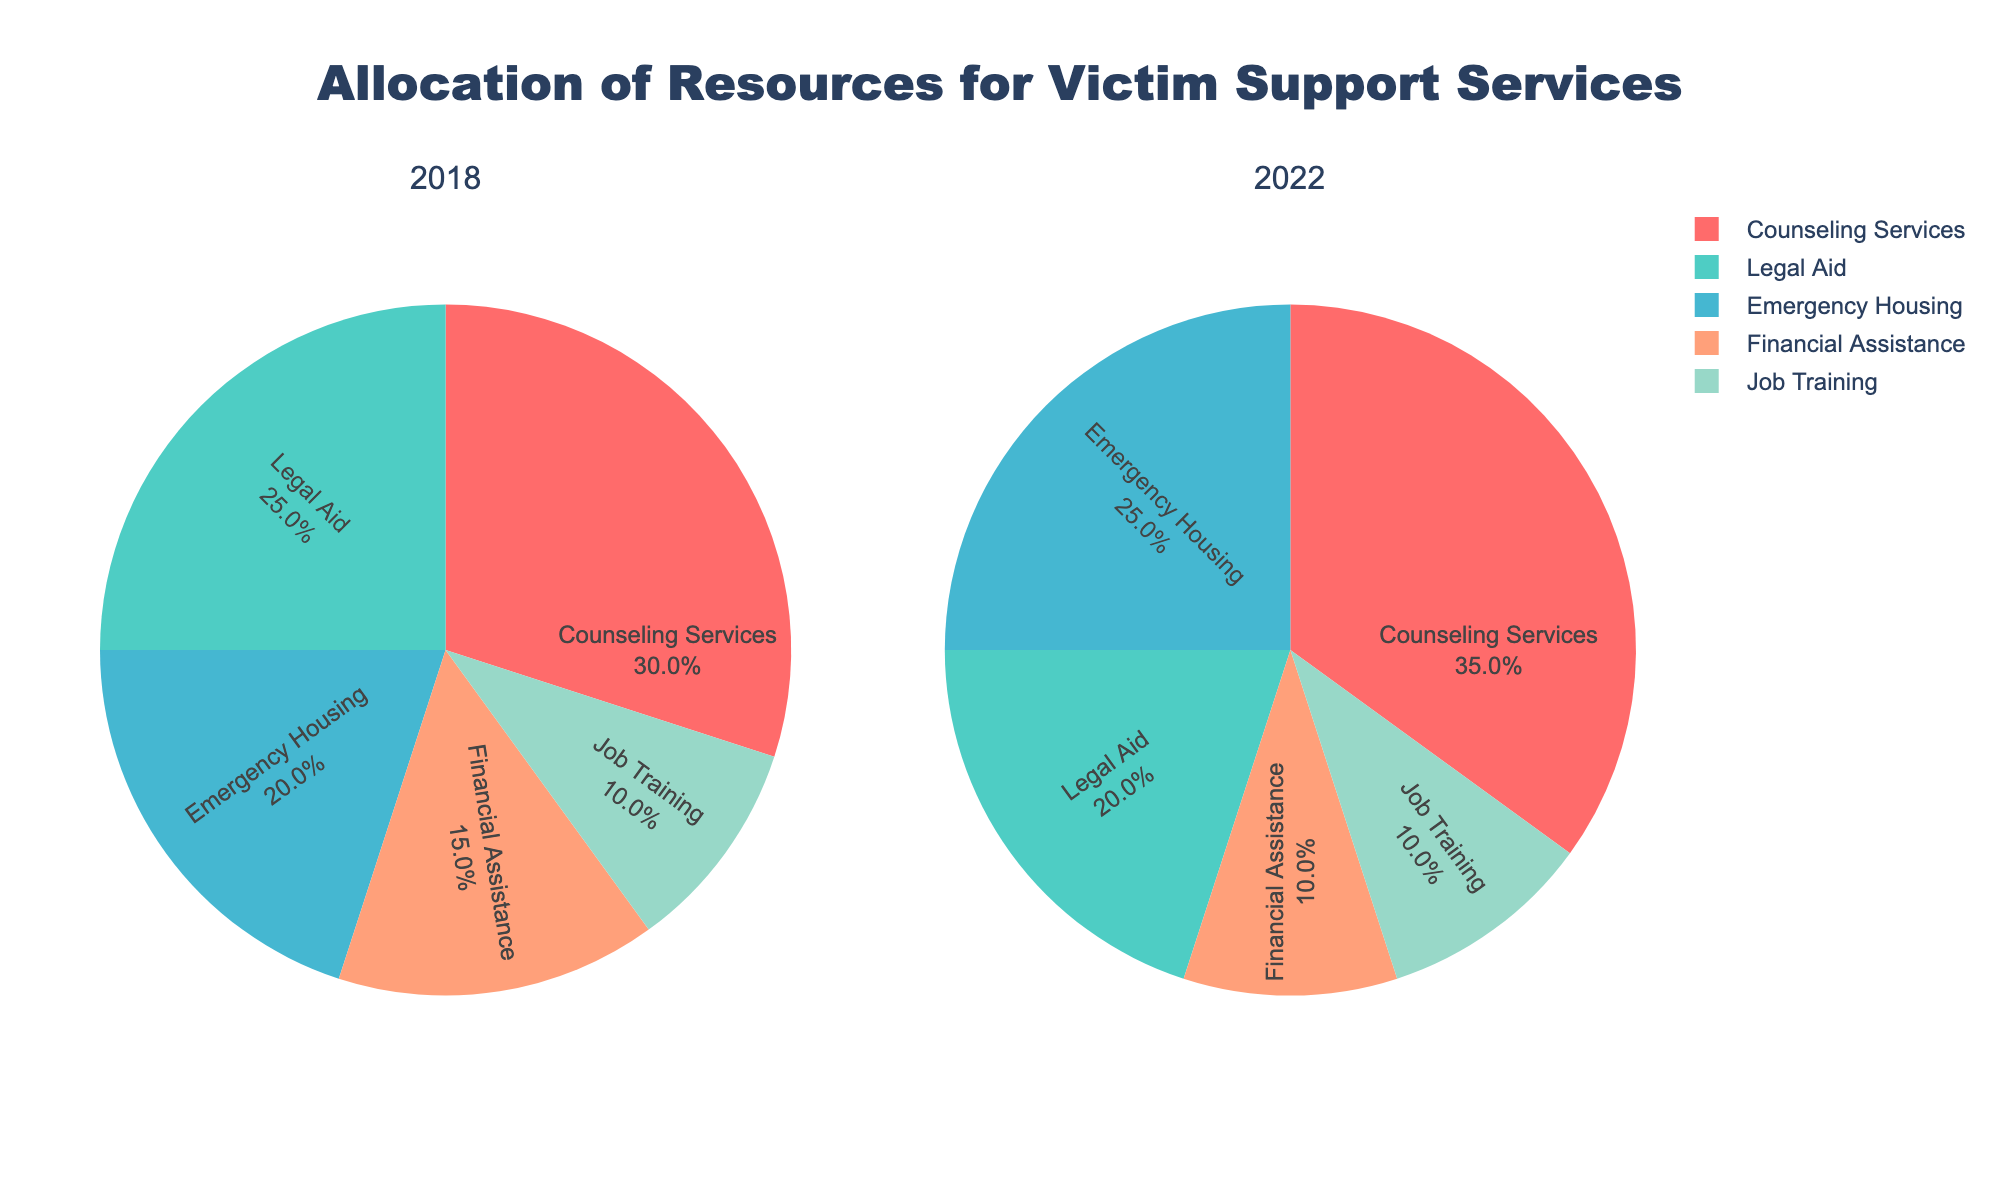What percentage of resources was allocated to legal aid in 2018? In the pie chart for 2018, the slice labeled "Legal Aid" shows a percentage. From the chart, the legal aid allocation is shown as 25%.
Answer: 25% What category had the highest percentage allocation in 2022? In the pie chart for 2022, observe which slice is the largest. The largest slice is labeled "Counseling Services," indicating that this category had the highest percentage allocation at 35%.
Answer: Counseling Services How much did the allocation for emergency housing change from 2018 to 2022? Compare the percentage of the emergency housing slices in both pie charts. In 2018, emergency housing was 20%, and in 2022, it was 25%. The change is 25% - 20% = 5%.
Answer: 5% Which two categories had the same percentage of resource allocation in 2022? Examine the pie chart for 2022 to identify categories with equal slices. Both "Financial Assistance" and "Job Training" are allocated 10% each.
Answer: Financial Assistance and Job Training What is the total percentage allocated to counseling services over both years? Add the percentages of counseling services from both pie charts. In 2018, it was 30%, and in 2022, it was 35%. The total is 30% + 35% = 65%.
Answer: 65% Which category saw a decrease in allocation percentage from 2018 to 2022? Study both pie charts and compare the slices to identify categories with reduced allocations. "Legal Aid" decreased from 25% in 2018 to 20% in 2022.
Answer: Legal Aid By how much did the allocation for financial assistance decrease from 2018 to 2022? Calculate the difference between the financial assistance percentages in both years. In 2018, it was 15%, and in 2022, it was 10%. The decrease is 15% - 10% = 5%.
Answer: 5% What is the combined percentage of resource allocation to job training over both years? Sum the job training percentages from 2018 and 2022. Both years have a 10% allocation for job training. The combined percentage is 10% + 10% = 20%.
Answer: 20% How does the allocation for emergency housing in 2022 compare to other categories in the same year? Look at the pie chart for 2022 and compare the percentage of emergency housing to other categories. Emergency Housing at 25% is higher than Legal Aid (20%), Financial Assistance (10%), and Job Training (10%) but lower than Counseling Services (35%).
Answer: Higher than Legal Aid, Financial Assistance, and Job Training but lower than Counseling Services 